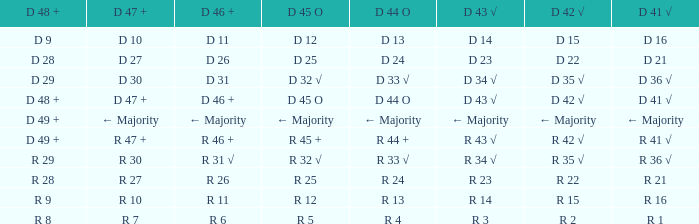What is the value of D 42 √, when the value of D 45 O is d 32 √? D 35 √. 